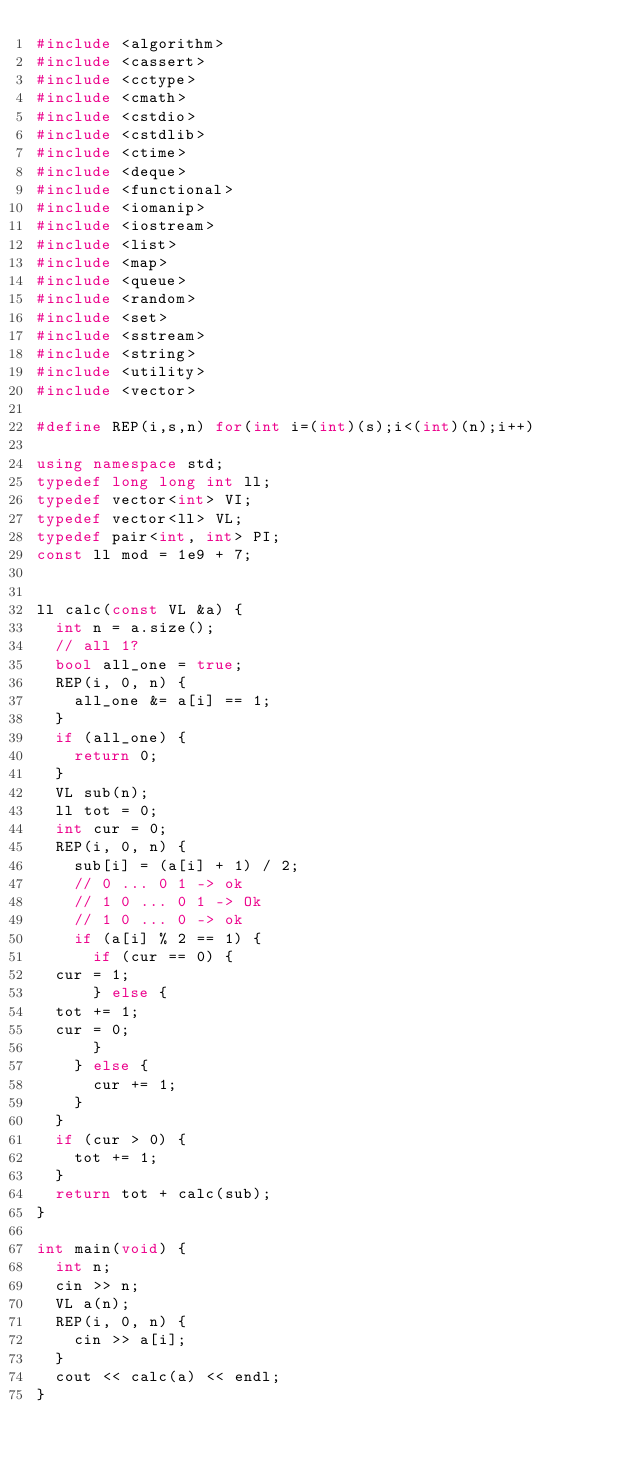Convert code to text. <code><loc_0><loc_0><loc_500><loc_500><_C++_>#include <algorithm>
#include <cassert>
#include <cctype>
#include <cmath>
#include <cstdio>
#include <cstdlib>
#include <ctime>
#include <deque>
#include <functional>
#include <iomanip>
#include <iostream>
#include <list>
#include <map>
#include <queue>
#include <random>
#include <set>
#include <sstream>
#include <string>
#include <utility>
#include <vector>

#define REP(i,s,n) for(int i=(int)(s);i<(int)(n);i++)

using namespace std;
typedef long long int ll;
typedef vector<int> VI;
typedef vector<ll> VL;
typedef pair<int, int> PI;
const ll mod = 1e9 + 7;


ll calc(const VL &a) {
  int n = a.size();
  // all 1?
  bool all_one = true;
  REP(i, 0, n) {
    all_one &= a[i] == 1;
  }
  if (all_one) {
    return 0;
  }
  VL sub(n);
  ll tot = 0;
  int cur = 0;
  REP(i, 0, n) {
    sub[i] = (a[i] + 1) / 2;
    // 0 ... 0 1 -> ok
    // 1 0 ... 0 1 -> Ok
    // 1 0 ... 0 -> ok
    if (a[i] % 2 == 1) {
      if (cur == 0) {
	cur = 1;
      } else {
	tot += 1;
	cur = 0;
      }
    } else {
      cur += 1;
    }
  }
  if (cur > 0) {
    tot += 1;
  }
  return tot + calc(sub);
}

int main(void) {
  int n;
  cin >> n;
  VL a(n);
  REP(i, 0, n) {
    cin >> a[i];
  }
  cout << calc(a) << endl;
}
</code> 